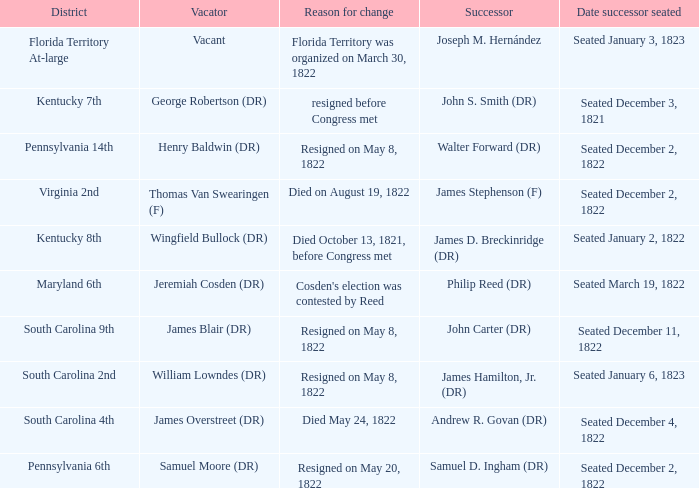Who is the vacator when south carolina 4th is the district? James Overstreet (DR). 